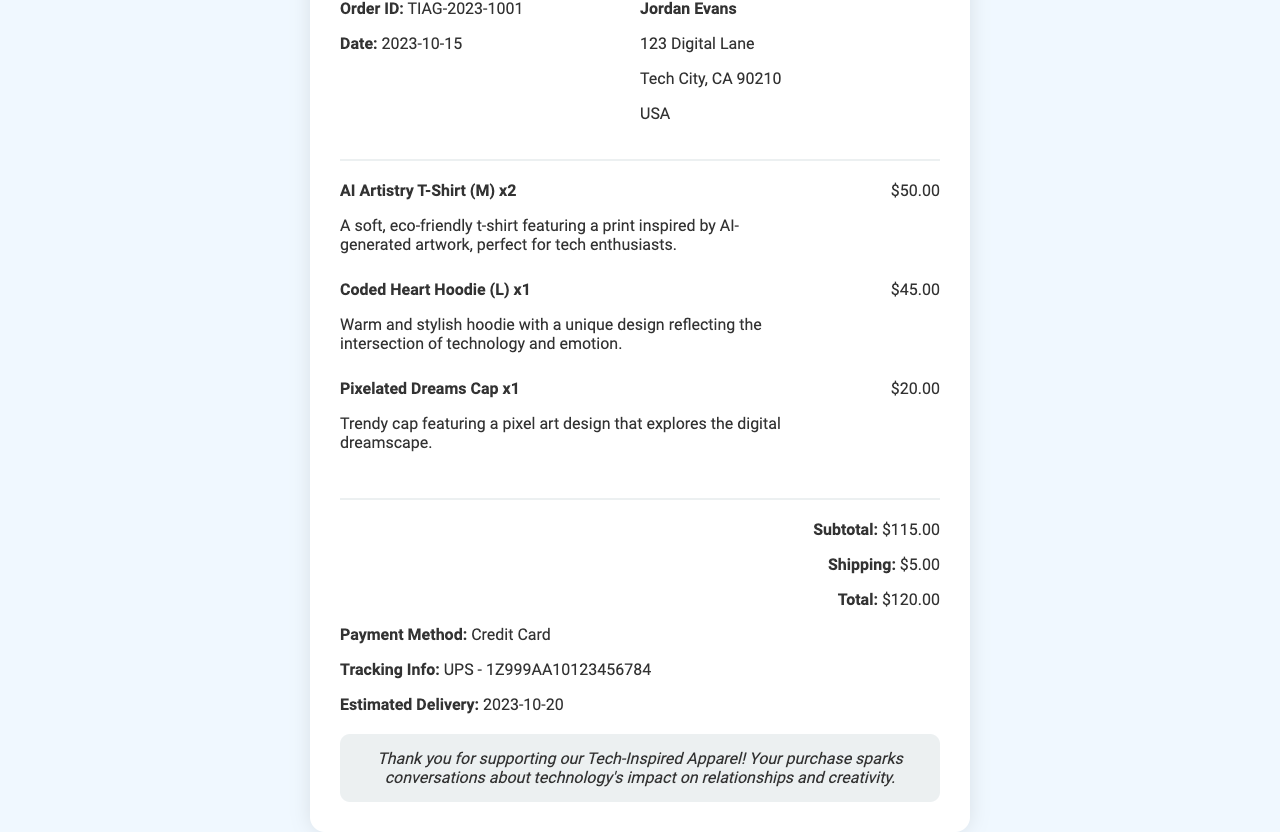what is the order ID? The order ID is a unique identifier for the transaction provided in the document.
Answer: TIAG-2023-1001 who is the customer? The customer's name is listed prominently in the receipt as the individual making the purchase.
Answer: Jordan Evans what is the subtotal amount? The subtotal represents the total cost of items purchased before shipping is added.
Answer: $115.00 how many "AI Artistry T-Shirt" were purchased? The quantity of this particular item is indicated next to its description on the receipt.
Answer: 2 what shipping method is used? The document specifies the carrier responsible for delivering the purchased items.
Answer: UPS what is the estimated delivery date? The document provides a date for when the purchased items are expected to arrive at the customer's address.
Answer: 2023-10-20 what is the total amount charged? The total amount charged encompasses the subtotal and shipping costs combined.
Answer: $120.00 what is the payment method? The mode of payment is mentioned in the document.
Answer: Credit Card how many different items were purchased? The document lists a number of unique products bought by the customer.
Answer: 3 